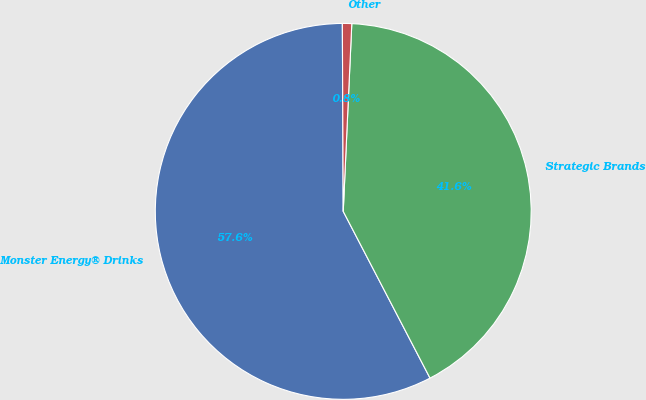Convert chart. <chart><loc_0><loc_0><loc_500><loc_500><pie_chart><fcel>Monster Energy® Drinks<fcel>Strategic Brands<fcel>Other<nl><fcel>57.57%<fcel>41.64%<fcel>0.8%<nl></chart> 